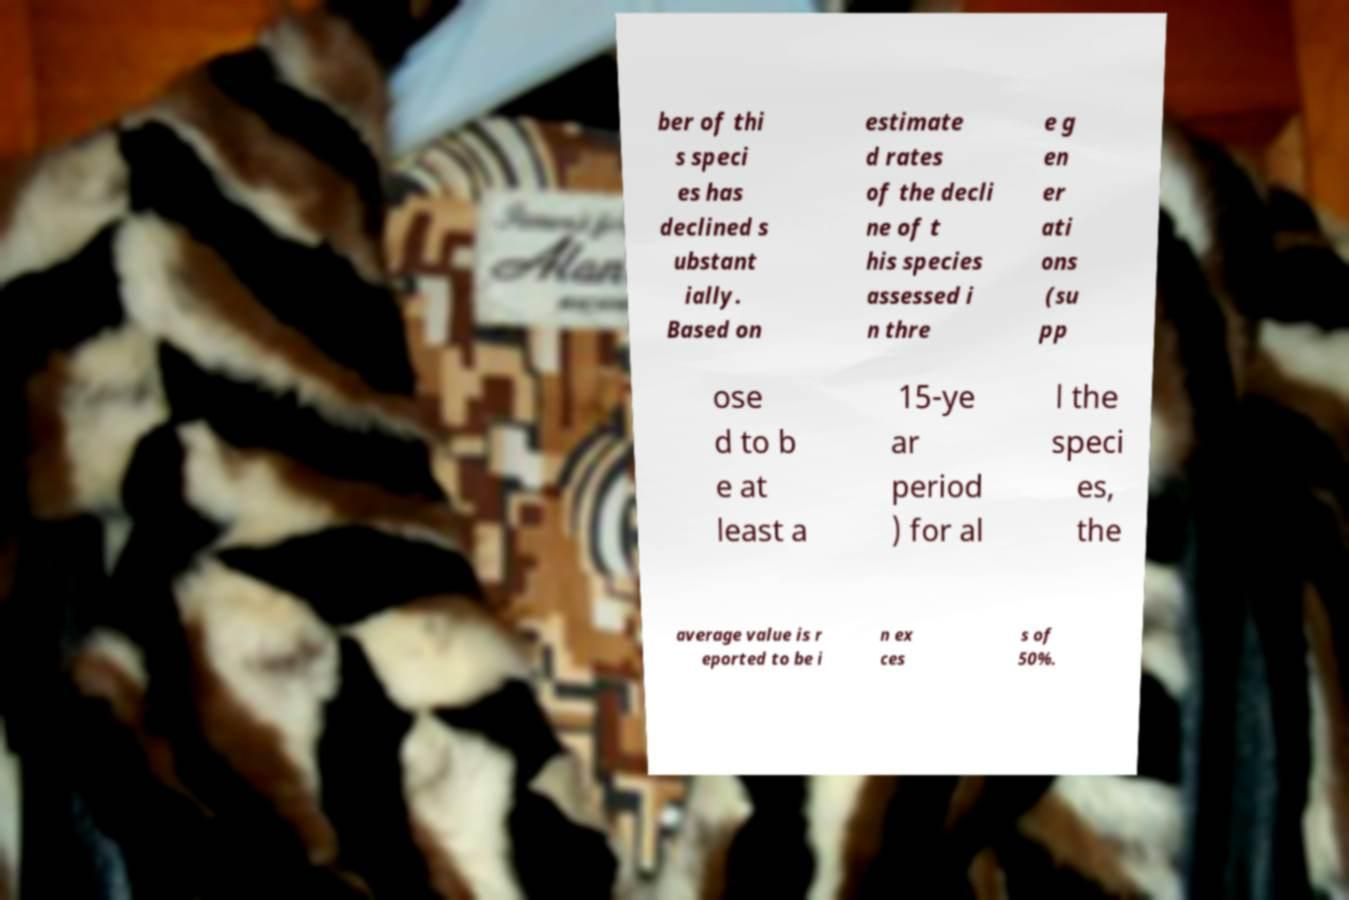Can you read and provide the text displayed in the image?This photo seems to have some interesting text. Can you extract and type it out for me? ber of thi s speci es has declined s ubstant ially. Based on estimate d rates of the decli ne of t his species assessed i n thre e g en er ati ons (su pp ose d to b e at least a 15-ye ar period ) for al l the speci es, the average value is r eported to be i n ex ces s of 50%. 